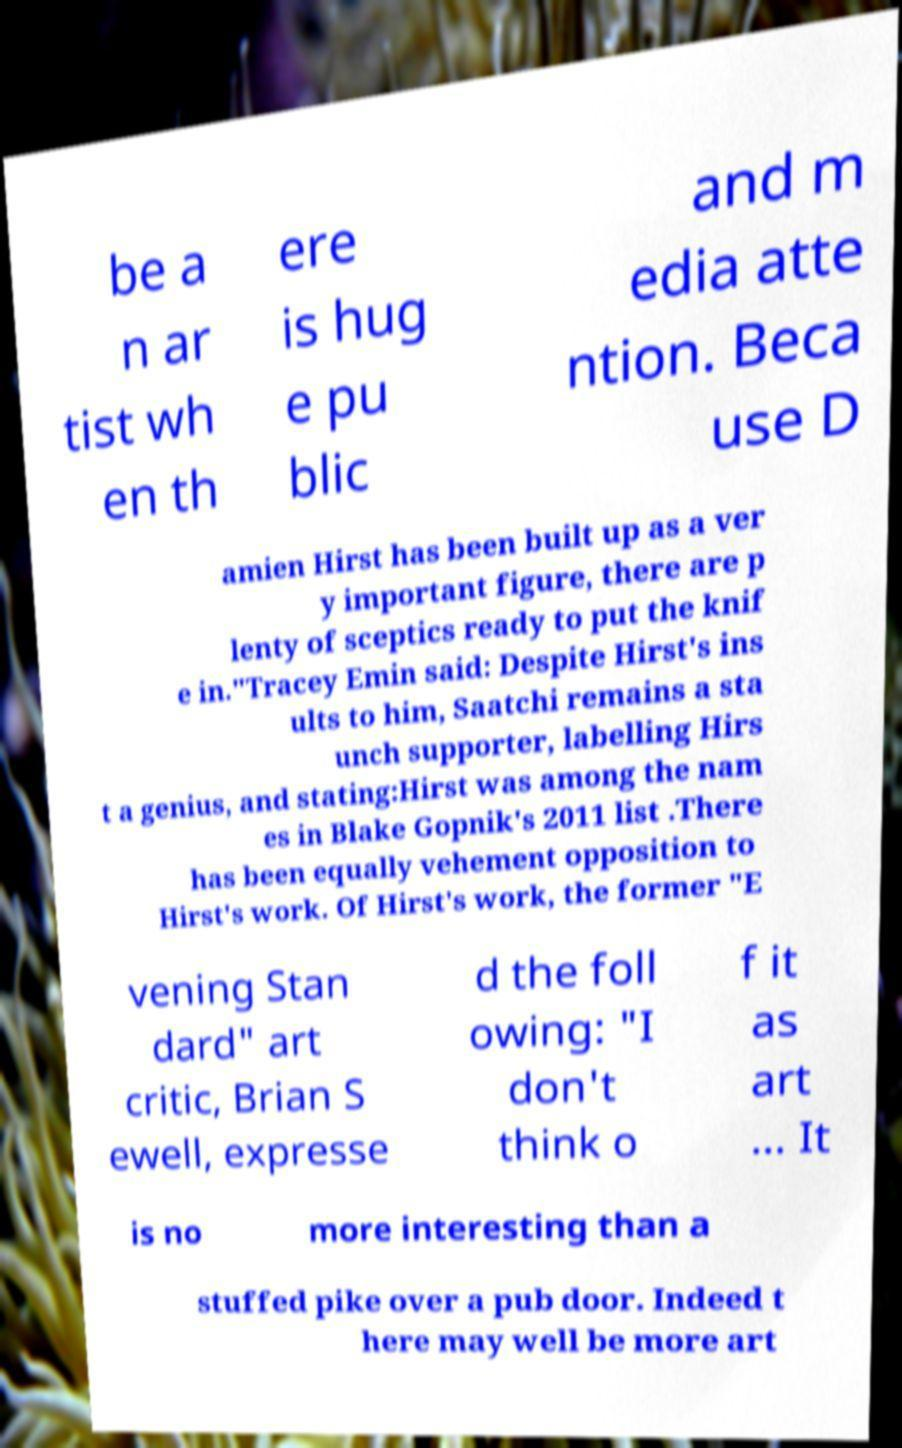For documentation purposes, I need the text within this image transcribed. Could you provide that? be a n ar tist wh en th ere is hug e pu blic and m edia atte ntion. Beca use D amien Hirst has been built up as a ver y important figure, there are p lenty of sceptics ready to put the knif e in."Tracey Emin said: Despite Hirst's ins ults to him, Saatchi remains a sta unch supporter, labelling Hirs t a genius, and stating:Hirst was among the nam es in Blake Gopnik's 2011 list .There has been equally vehement opposition to Hirst's work. Of Hirst's work, the former "E vening Stan dard" art critic, Brian S ewell, expresse d the foll owing: "I don't think o f it as art ... It is no more interesting than a stuffed pike over a pub door. Indeed t here may well be more art 